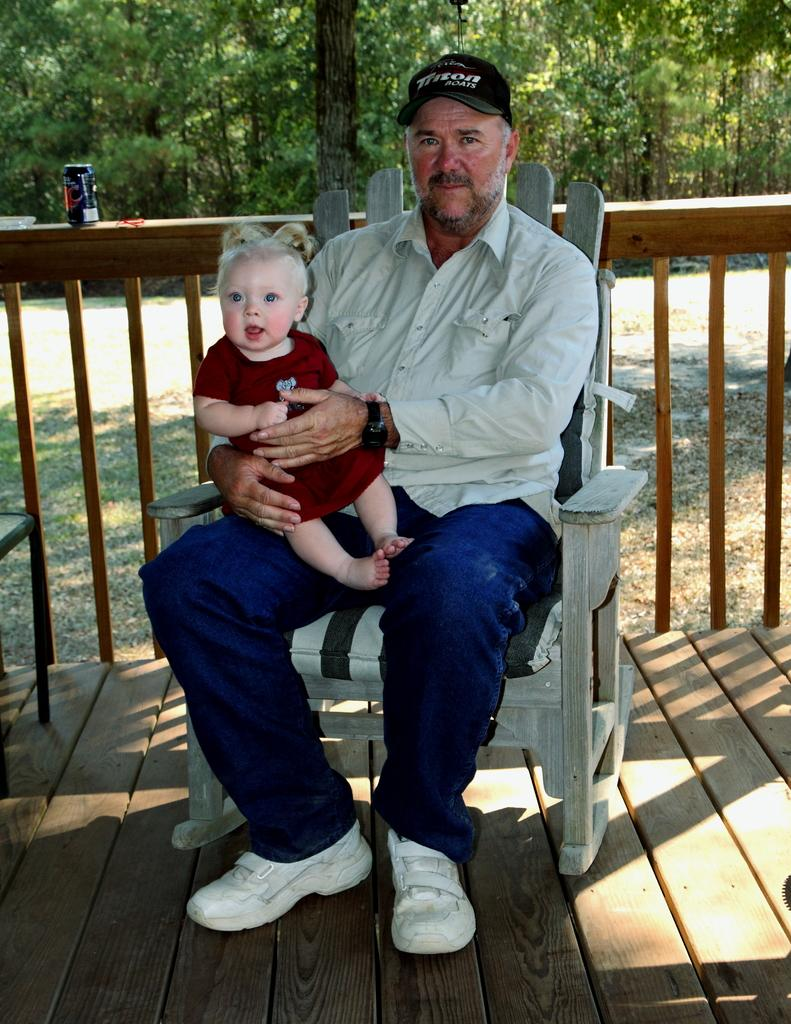Who is present in the image? There is a man and a boy in the image. What are the man and the boy doing in the image? Both the man and the boy are seated on a chair. What can be seen in the background of the image? There are trees visible in the background of the image. What type of structure is present in the image? There is a wooden fence in the image. What type of reward can be seen in the image? There is no reward present in the image. How many marbles are visible on the wooden fence in the image? There are no marbles present on the wooden fence in the image. 